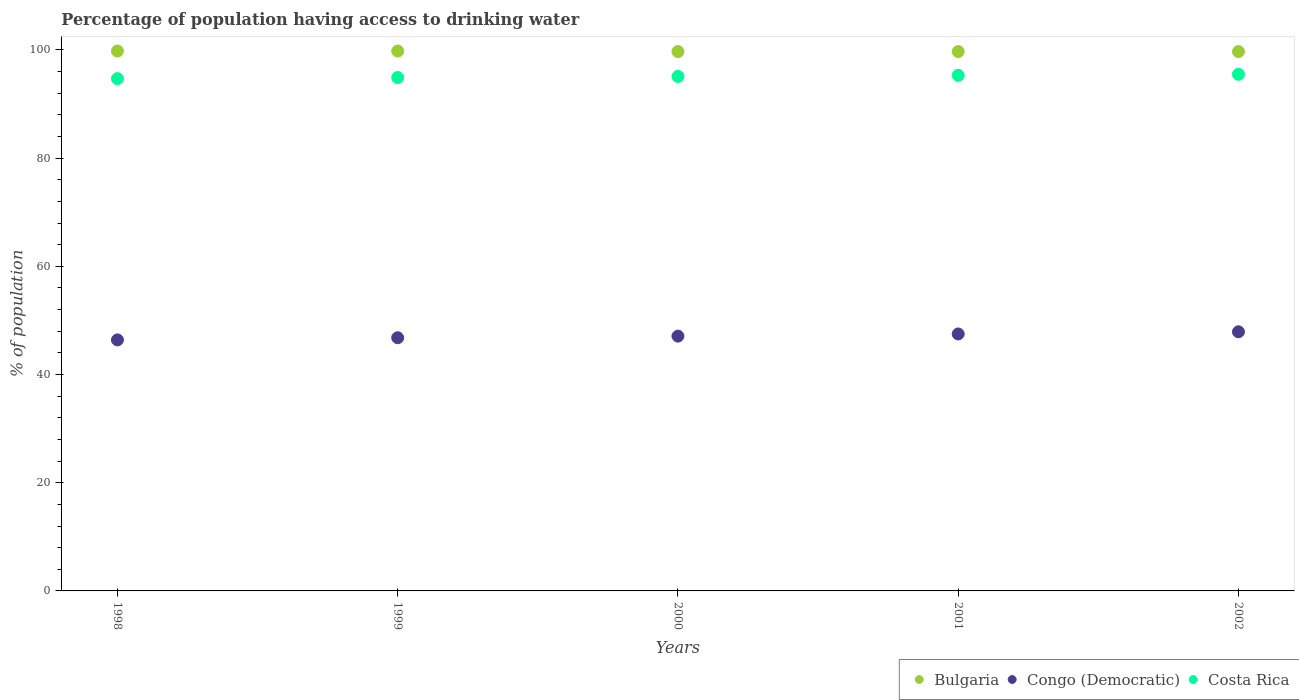Is the number of dotlines equal to the number of legend labels?
Give a very brief answer. Yes. What is the percentage of population having access to drinking water in Costa Rica in 1998?
Your response must be concise. 94.7. Across all years, what is the maximum percentage of population having access to drinking water in Congo (Democratic)?
Offer a terse response. 47.9. Across all years, what is the minimum percentage of population having access to drinking water in Congo (Democratic)?
Offer a terse response. 46.4. In which year was the percentage of population having access to drinking water in Bulgaria maximum?
Provide a succinct answer. 1998. What is the total percentage of population having access to drinking water in Costa Rica in the graph?
Provide a succinct answer. 475.5. What is the difference between the percentage of population having access to drinking water in Costa Rica in 1998 and that in 2000?
Your response must be concise. -0.4. What is the difference between the percentage of population having access to drinking water in Congo (Democratic) in 2002 and the percentage of population having access to drinking water in Costa Rica in 2000?
Ensure brevity in your answer.  -47.2. What is the average percentage of population having access to drinking water in Bulgaria per year?
Ensure brevity in your answer.  99.74. In the year 2002, what is the difference between the percentage of population having access to drinking water in Bulgaria and percentage of population having access to drinking water in Congo (Democratic)?
Your answer should be very brief. 51.8. What is the ratio of the percentage of population having access to drinking water in Costa Rica in 2000 to that in 2002?
Your response must be concise. 1. What is the difference between the highest and the second highest percentage of population having access to drinking water in Congo (Democratic)?
Offer a terse response. 0.4. What is the difference between the highest and the lowest percentage of population having access to drinking water in Bulgaria?
Ensure brevity in your answer.  0.1. Is it the case that in every year, the sum of the percentage of population having access to drinking water in Congo (Democratic) and percentage of population having access to drinking water in Bulgaria  is greater than the percentage of population having access to drinking water in Costa Rica?
Keep it short and to the point. Yes. Is the percentage of population having access to drinking water in Bulgaria strictly greater than the percentage of population having access to drinking water in Costa Rica over the years?
Keep it short and to the point. Yes. How many years are there in the graph?
Your answer should be very brief. 5. What is the difference between two consecutive major ticks on the Y-axis?
Your answer should be very brief. 20. Are the values on the major ticks of Y-axis written in scientific E-notation?
Your response must be concise. No. Where does the legend appear in the graph?
Make the answer very short. Bottom right. How many legend labels are there?
Offer a very short reply. 3. How are the legend labels stacked?
Provide a short and direct response. Horizontal. What is the title of the graph?
Your answer should be very brief. Percentage of population having access to drinking water. Does "Czech Republic" appear as one of the legend labels in the graph?
Give a very brief answer. No. What is the label or title of the Y-axis?
Make the answer very short. % of population. What is the % of population of Bulgaria in 1998?
Give a very brief answer. 99.8. What is the % of population in Congo (Democratic) in 1998?
Your response must be concise. 46.4. What is the % of population of Costa Rica in 1998?
Offer a very short reply. 94.7. What is the % of population in Bulgaria in 1999?
Your response must be concise. 99.8. What is the % of population in Congo (Democratic) in 1999?
Offer a very short reply. 46.8. What is the % of population in Costa Rica in 1999?
Make the answer very short. 94.9. What is the % of population in Bulgaria in 2000?
Provide a succinct answer. 99.7. What is the % of population in Congo (Democratic) in 2000?
Ensure brevity in your answer.  47.1. What is the % of population in Costa Rica in 2000?
Give a very brief answer. 95.1. What is the % of population of Bulgaria in 2001?
Keep it short and to the point. 99.7. What is the % of population in Congo (Democratic) in 2001?
Offer a terse response. 47.5. What is the % of population in Costa Rica in 2001?
Make the answer very short. 95.3. What is the % of population of Bulgaria in 2002?
Ensure brevity in your answer.  99.7. What is the % of population in Congo (Democratic) in 2002?
Offer a very short reply. 47.9. What is the % of population in Costa Rica in 2002?
Provide a succinct answer. 95.5. Across all years, what is the maximum % of population in Bulgaria?
Offer a very short reply. 99.8. Across all years, what is the maximum % of population of Congo (Democratic)?
Give a very brief answer. 47.9. Across all years, what is the maximum % of population in Costa Rica?
Your response must be concise. 95.5. Across all years, what is the minimum % of population in Bulgaria?
Provide a short and direct response. 99.7. Across all years, what is the minimum % of population of Congo (Democratic)?
Keep it short and to the point. 46.4. Across all years, what is the minimum % of population of Costa Rica?
Make the answer very short. 94.7. What is the total % of population in Bulgaria in the graph?
Offer a terse response. 498.7. What is the total % of population in Congo (Democratic) in the graph?
Offer a very short reply. 235.7. What is the total % of population of Costa Rica in the graph?
Your answer should be very brief. 475.5. What is the difference between the % of population in Congo (Democratic) in 1998 and that in 1999?
Give a very brief answer. -0.4. What is the difference between the % of population in Costa Rica in 1998 and that in 1999?
Offer a very short reply. -0.2. What is the difference between the % of population in Bulgaria in 1998 and that in 2000?
Your answer should be very brief. 0.1. What is the difference between the % of population in Congo (Democratic) in 1998 and that in 2000?
Ensure brevity in your answer.  -0.7. What is the difference between the % of population of Costa Rica in 1998 and that in 2000?
Offer a terse response. -0.4. What is the difference between the % of population in Bulgaria in 1998 and that in 2001?
Provide a short and direct response. 0.1. What is the difference between the % of population in Congo (Democratic) in 1998 and that in 2001?
Provide a succinct answer. -1.1. What is the difference between the % of population of Bulgaria in 1998 and that in 2002?
Provide a short and direct response. 0.1. What is the difference between the % of population in Congo (Democratic) in 1998 and that in 2002?
Ensure brevity in your answer.  -1.5. What is the difference between the % of population in Costa Rica in 1998 and that in 2002?
Provide a short and direct response. -0.8. What is the difference between the % of population of Bulgaria in 1999 and that in 2000?
Offer a terse response. 0.1. What is the difference between the % of population of Congo (Democratic) in 1999 and that in 2000?
Your answer should be compact. -0.3. What is the difference between the % of population in Bulgaria in 1999 and that in 2001?
Your answer should be compact. 0.1. What is the difference between the % of population of Congo (Democratic) in 1999 and that in 2001?
Keep it short and to the point. -0.7. What is the difference between the % of population of Bulgaria in 1999 and that in 2002?
Ensure brevity in your answer.  0.1. What is the difference between the % of population of Congo (Democratic) in 1999 and that in 2002?
Your answer should be compact. -1.1. What is the difference between the % of population in Costa Rica in 1999 and that in 2002?
Ensure brevity in your answer.  -0.6. What is the difference between the % of population in Bulgaria in 2000 and that in 2001?
Offer a very short reply. 0. What is the difference between the % of population of Congo (Democratic) in 2000 and that in 2001?
Give a very brief answer. -0.4. What is the difference between the % of population in Costa Rica in 2000 and that in 2001?
Offer a terse response. -0.2. What is the difference between the % of population in Congo (Democratic) in 2000 and that in 2002?
Give a very brief answer. -0.8. What is the difference between the % of population in Costa Rica in 2000 and that in 2002?
Offer a very short reply. -0.4. What is the difference between the % of population in Bulgaria in 2001 and that in 2002?
Make the answer very short. 0. What is the difference between the % of population of Bulgaria in 1998 and the % of population of Congo (Democratic) in 1999?
Make the answer very short. 53. What is the difference between the % of population of Bulgaria in 1998 and the % of population of Costa Rica in 1999?
Your answer should be very brief. 4.9. What is the difference between the % of population in Congo (Democratic) in 1998 and the % of population in Costa Rica in 1999?
Make the answer very short. -48.5. What is the difference between the % of population in Bulgaria in 1998 and the % of population in Congo (Democratic) in 2000?
Your response must be concise. 52.7. What is the difference between the % of population of Bulgaria in 1998 and the % of population of Costa Rica in 2000?
Your answer should be compact. 4.7. What is the difference between the % of population of Congo (Democratic) in 1998 and the % of population of Costa Rica in 2000?
Make the answer very short. -48.7. What is the difference between the % of population of Bulgaria in 1998 and the % of population of Congo (Democratic) in 2001?
Your answer should be compact. 52.3. What is the difference between the % of population of Bulgaria in 1998 and the % of population of Costa Rica in 2001?
Give a very brief answer. 4.5. What is the difference between the % of population in Congo (Democratic) in 1998 and the % of population in Costa Rica in 2001?
Provide a short and direct response. -48.9. What is the difference between the % of population of Bulgaria in 1998 and the % of population of Congo (Democratic) in 2002?
Give a very brief answer. 51.9. What is the difference between the % of population in Bulgaria in 1998 and the % of population in Costa Rica in 2002?
Your answer should be very brief. 4.3. What is the difference between the % of population in Congo (Democratic) in 1998 and the % of population in Costa Rica in 2002?
Provide a succinct answer. -49.1. What is the difference between the % of population of Bulgaria in 1999 and the % of population of Congo (Democratic) in 2000?
Keep it short and to the point. 52.7. What is the difference between the % of population of Congo (Democratic) in 1999 and the % of population of Costa Rica in 2000?
Offer a very short reply. -48.3. What is the difference between the % of population of Bulgaria in 1999 and the % of population of Congo (Democratic) in 2001?
Your response must be concise. 52.3. What is the difference between the % of population of Congo (Democratic) in 1999 and the % of population of Costa Rica in 2001?
Provide a short and direct response. -48.5. What is the difference between the % of population in Bulgaria in 1999 and the % of population in Congo (Democratic) in 2002?
Provide a short and direct response. 51.9. What is the difference between the % of population in Congo (Democratic) in 1999 and the % of population in Costa Rica in 2002?
Keep it short and to the point. -48.7. What is the difference between the % of population of Bulgaria in 2000 and the % of population of Congo (Democratic) in 2001?
Ensure brevity in your answer.  52.2. What is the difference between the % of population of Congo (Democratic) in 2000 and the % of population of Costa Rica in 2001?
Ensure brevity in your answer.  -48.2. What is the difference between the % of population of Bulgaria in 2000 and the % of population of Congo (Democratic) in 2002?
Ensure brevity in your answer.  51.8. What is the difference between the % of population in Congo (Democratic) in 2000 and the % of population in Costa Rica in 2002?
Provide a succinct answer. -48.4. What is the difference between the % of population of Bulgaria in 2001 and the % of population of Congo (Democratic) in 2002?
Your answer should be compact. 51.8. What is the difference between the % of population in Bulgaria in 2001 and the % of population in Costa Rica in 2002?
Give a very brief answer. 4.2. What is the difference between the % of population of Congo (Democratic) in 2001 and the % of population of Costa Rica in 2002?
Ensure brevity in your answer.  -48. What is the average % of population of Bulgaria per year?
Your answer should be very brief. 99.74. What is the average % of population of Congo (Democratic) per year?
Make the answer very short. 47.14. What is the average % of population of Costa Rica per year?
Your response must be concise. 95.1. In the year 1998, what is the difference between the % of population of Bulgaria and % of population of Congo (Democratic)?
Offer a very short reply. 53.4. In the year 1998, what is the difference between the % of population in Bulgaria and % of population in Costa Rica?
Offer a terse response. 5.1. In the year 1998, what is the difference between the % of population in Congo (Democratic) and % of population in Costa Rica?
Give a very brief answer. -48.3. In the year 1999, what is the difference between the % of population of Bulgaria and % of population of Congo (Democratic)?
Your answer should be compact. 53. In the year 1999, what is the difference between the % of population in Congo (Democratic) and % of population in Costa Rica?
Your response must be concise. -48.1. In the year 2000, what is the difference between the % of population in Bulgaria and % of population in Congo (Democratic)?
Provide a succinct answer. 52.6. In the year 2000, what is the difference between the % of population in Bulgaria and % of population in Costa Rica?
Offer a terse response. 4.6. In the year 2000, what is the difference between the % of population in Congo (Democratic) and % of population in Costa Rica?
Give a very brief answer. -48. In the year 2001, what is the difference between the % of population in Bulgaria and % of population in Congo (Democratic)?
Provide a succinct answer. 52.2. In the year 2001, what is the difference between the % of population in Congo (Democratic) and % of population in Costa Rica?
Give a very brief answer. -47.8. In the year 2002, what is the difference between the % of population of Bulgaria and % of population of Congo (Democratic)?
Make the answer very short. 51.8. In the year 2002, what is the difference between the % of population of Congo (Democratic) and % of population of Costa Rica?
Give a very brief answer. -47.6. What is the ratio of the % of population of Congo (Democratic) in 1998 to that in 1999?
Make the answer very short. 0.99. What is the ratio of the % of population in Congo (Democratic) in 1998 to that in 2000?
Your answer should be very brief. 0.99. What is the ratio of the % of population in Bulgaria in 1998 to that in 2001?
Provide a succinct answer. 1. What is the ratio of the % of population of Congo (Democratic) in 1998 to that in 2001?
Provide a short and direct response. 0.98. What is the ratio of the % of population in Costa Rica in 1998 to that in 2001?
Provide a short and direct response. 0.99. What is the ratio of the % of population of Bulgaria in 1998 to that in 2002?
Offer a terse response. 1. What is the ratio of the % of population of Congo (Democratic) in 1998 to that in 2002?
Your answer should be compact. 0.97. What is the ratio of the % of population in Costa Rica in 1998 to that in 2002?
Provide a short and direct response. 0.99. What is the ratio of the % of population of Congo (Democratic) in 1999 to that in 2000?
Offer a very short reply. 0.99. What is the ratio of the % of population of Bulgaria in 1999 to that in 2001?
Provide a succinct answer. 1. What is the ratio of the % of population in Costa Rica in 1999 to that in 2001?
Your answer should be very brief. 1. What is the ratio of the % of population in Congo (Democratic) in 1999 to that in 2002?
Your answer should be very brief. 0.98. What is the ratio of the % of population of Costa Rica in 1999 to that in 2002?
Offer a very short reply. 0.99. What is the ratio of the % of population of Congo (Democratic) in 2000 to that in 2002?
Provide a succinct answer. 0.98. What is the ratio of the % of population of Congo (Democratic) in 2001 to that in 2002?
Provide a short and direct response. 0.99. What is the ratio of the % of population in Costa Rica in 2001 to that in 2002?
Your answer should be compact. 1. What is the difference between the highest and the lowest % of population in Congo (Democratic)?
Offer a very short reply. 1.5. What is the difference between the highest and the lowest % of population of Costa Rica?
Your answer should be compact. 0.8. 